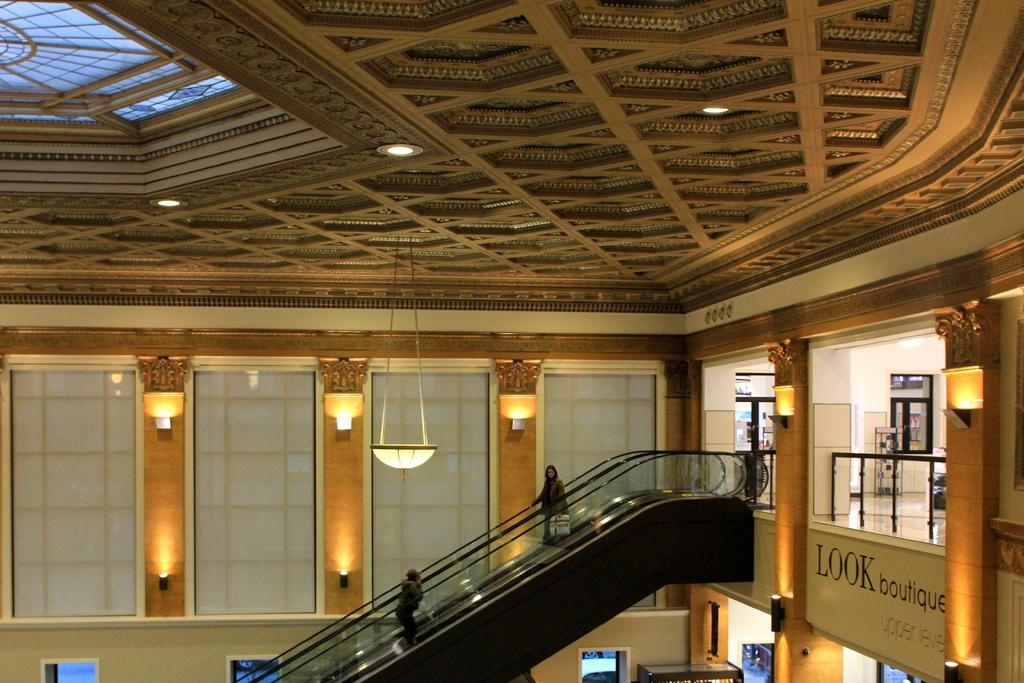What type of structure is present in the image? There is an elevator in the image. What is visible at the top of the image? There is a roof visible at the top of the image. What can be seen in the background of the image? There is a wall in the background of the image. How does the straw affect the crowd during the war in the image? There is no crowd, war, or straw present in the image. The image only features an elevator, a roof, and a wall. 